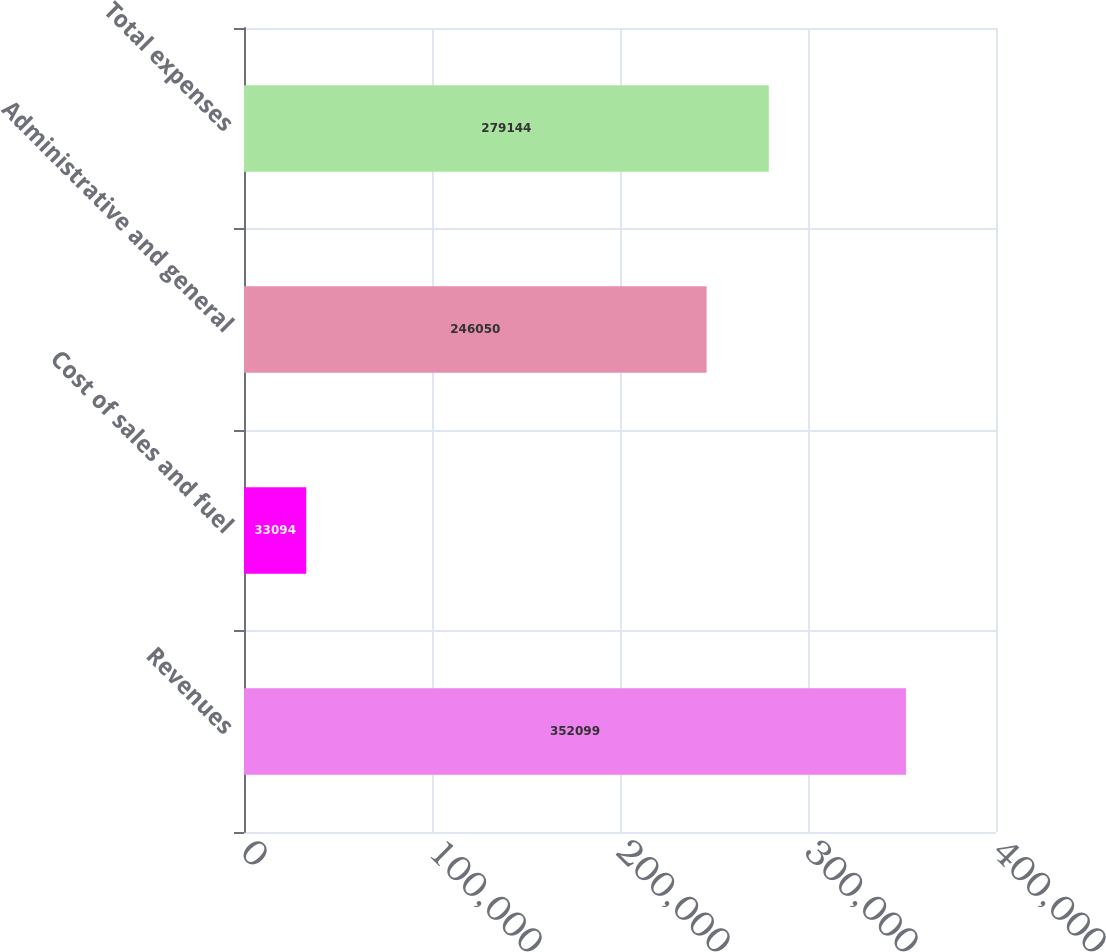Convert chart to OTSL. <chart><loc_0><loc_0><loc_500><loc_500><bar_chart><fcel>Revenues<fcel>Cost of sales and fuel<fcel>Administrative and general<fcel>Total expenses<nl><fcel>352099<fcel>33094<fcel>246050<fcel>279144<nl></chart> 